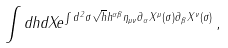<formula> <loc_0><loc_0><loc_500><loc_500>\int d h d X e ^ { \int d ^ { 2 } \sigma \sqrt { h } h ^ { \alpha \beta } \eta _ { \mu \nu } \partial _ { \alpha } X ^ { \mu } ( \sigma ) \partial _ { \beta } X ^ { \nu } ( \sigma ) } \, ,</formula> 